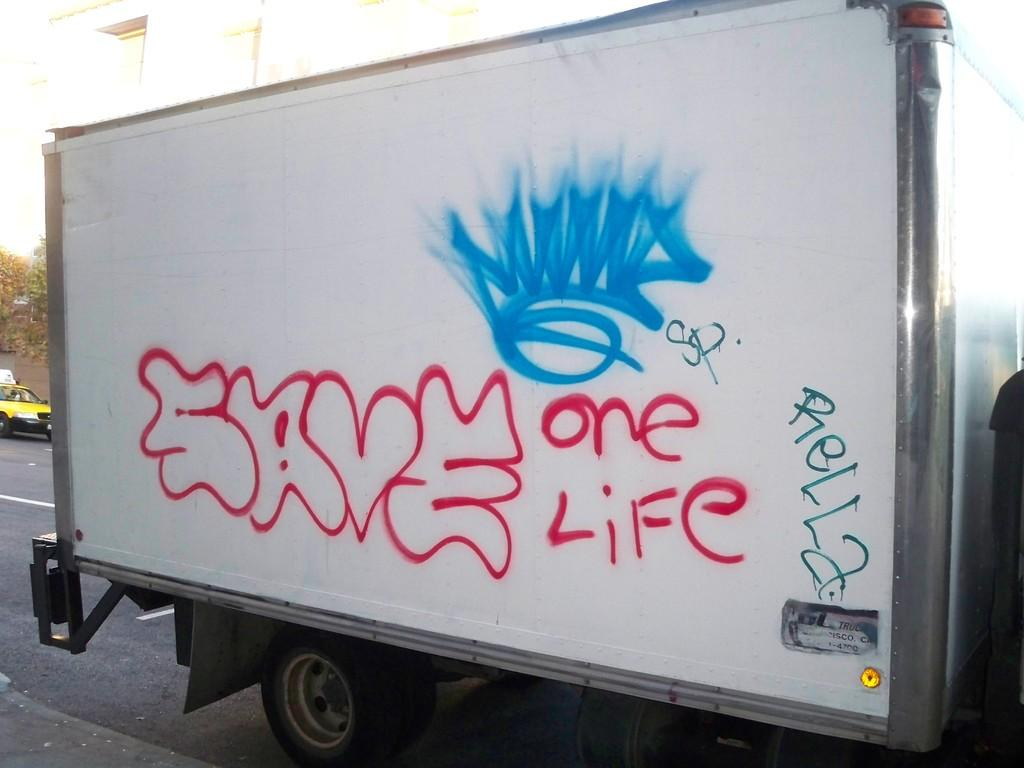What is the main subject of the image? There is a vehicle in the image. What can be seen in the background of the image? The background of the image is white. Are there any additional details on the vehicle? Yes, there is text or writing on the vehicle. What type of veil is draped over the vehicle in the image? There is no veil present on the vehicle in the image. Can you tell me how many jars are visible on the vehicle? There are no jars visible on the vehicle in the image. 